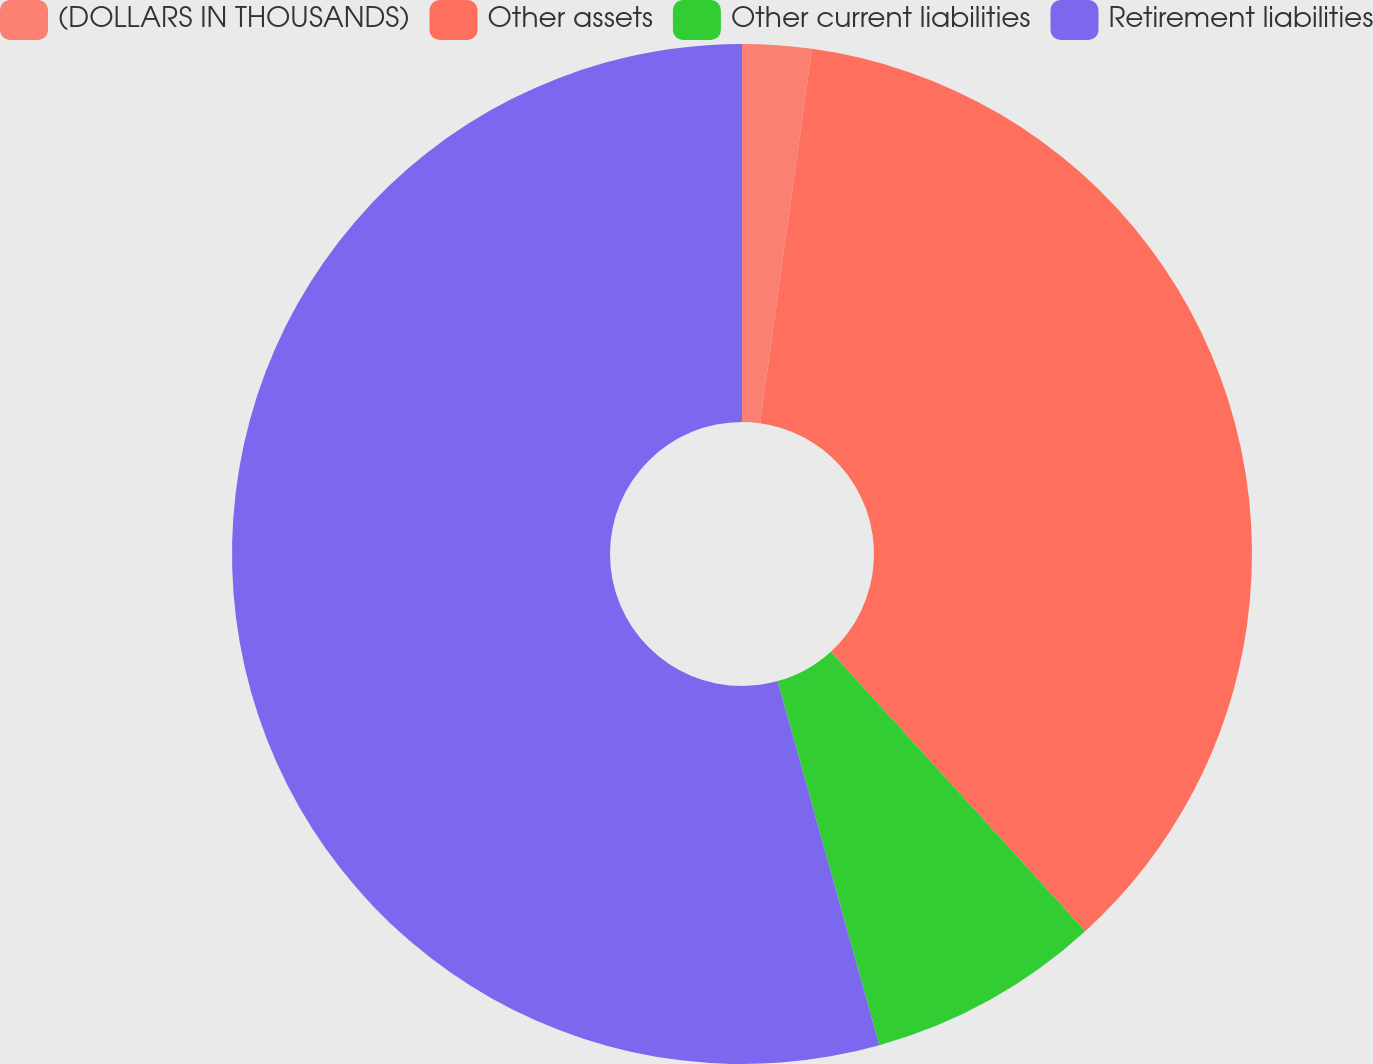Convert chart. <chart><loc_0><loc_0><loc_500><loc_500><pie_chart><fcel>(DOLLARS IN THOUSANDS)<fcel>Other assets<fcel>Other current liabilities<fcel>Retirement liabilities<nl><fcel>2.19%<fcel>36.06%<fcel>7.41%<fcel>54.34%<nl></chart> 